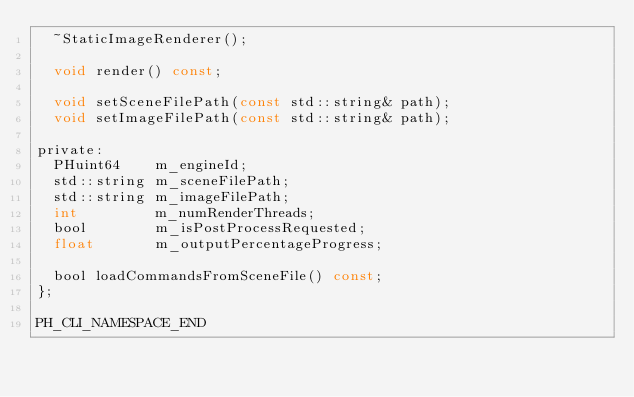<code> <loc_0><loc_0><loc_500><loc_500><_C_>	~StaticImageRenderer();

	void render() const;

	void setSceneFilePath(const std::string& path);
	void setImageFilePath(const std::string& path);

private:
	PHuint64    m_engineId;
	std::string m_sceneFilePath;
	std::string m_imageFilePath;
	int         m_numRenderThreads;
	bool        m_isPostProcessRequested;
	float       m_outputPercentageProgress;

	bool loadCommandsFromSceneFile() const;
};

PH_CLI_NAMESPACE_END</code> 